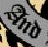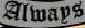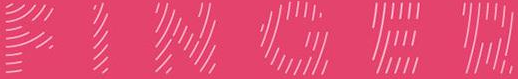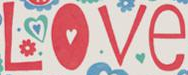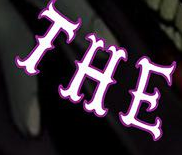What words can you see in these images in sequence, separated by a semicolon? And; Always; FINGER; Love; THE 